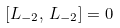Convert formula to latex. <formula><loc_0><loc_0><loc_500><loc_500>[ L _ { - 2 } , \, L _ { - 2 } ] = 0</formula> 